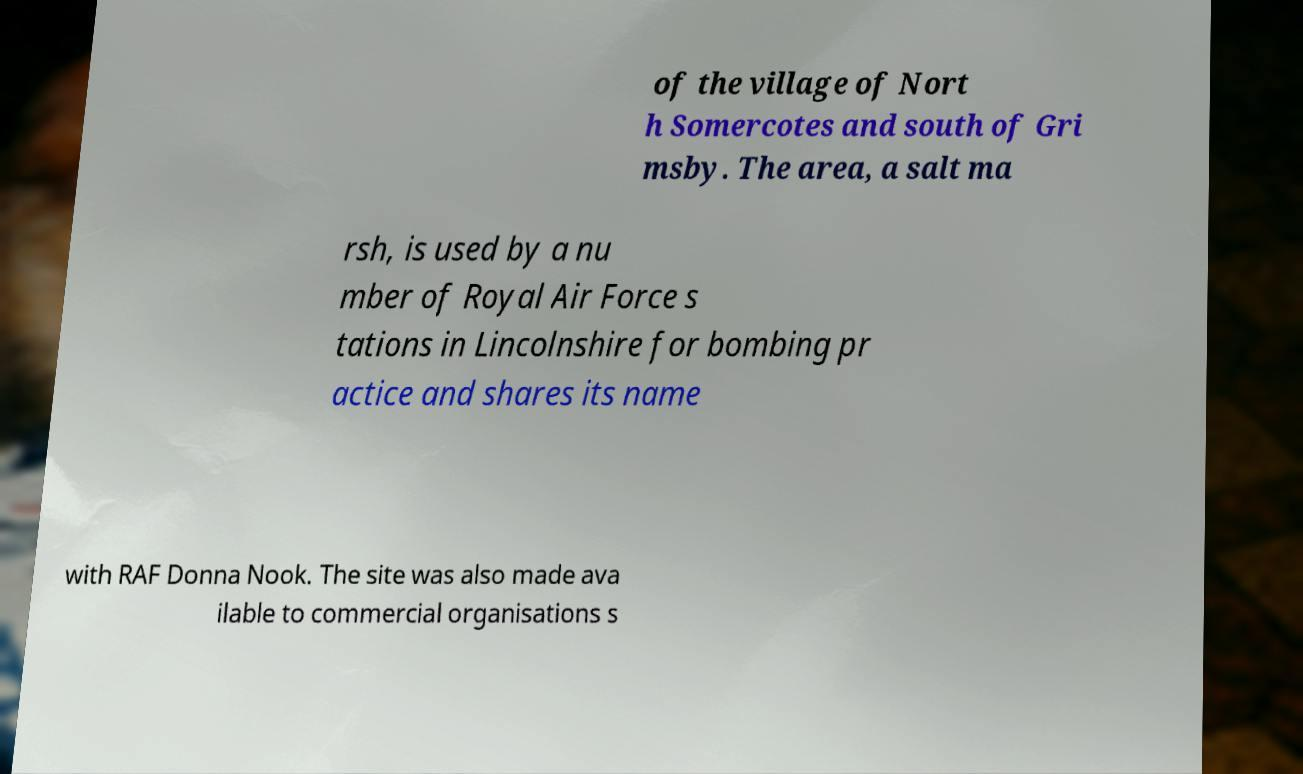I need the written content from this picture converted into text. Can you do that? of the village of Nort h Somercotes and south of Gri msby. The area, a salt ma rsh, is used by a nu mber of Royal Air Force s tations in Lincolnshire for bombing pr actice and shares its name with RAF Donna Nook. The site was also made ava ilable to commercial organisations s 